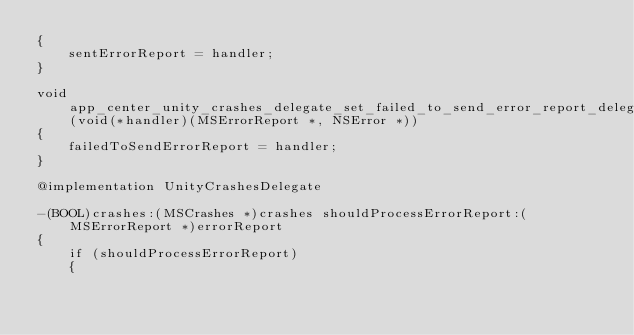Convert code to text. <code><loc_0><loc_0><loc_500><loc_500><_ObjectiveC_>{
    sentErrorReport = handler;
}

void app_center_unity_crashes_delegate_set_failed_to_send_error_report_delegate(void(*handler)(MSErrorReport *, NSError *))
{
    failedToSendErrorReport = handler;
}

@implementation UnityCrashesDelegate

-(BOOL)crashes:(MSCrashes *)crashes shouldProcessErrorReport:(MSErrorReport *)errorReport
{
    if (shouldProcessErrorReport)
    {</code> 